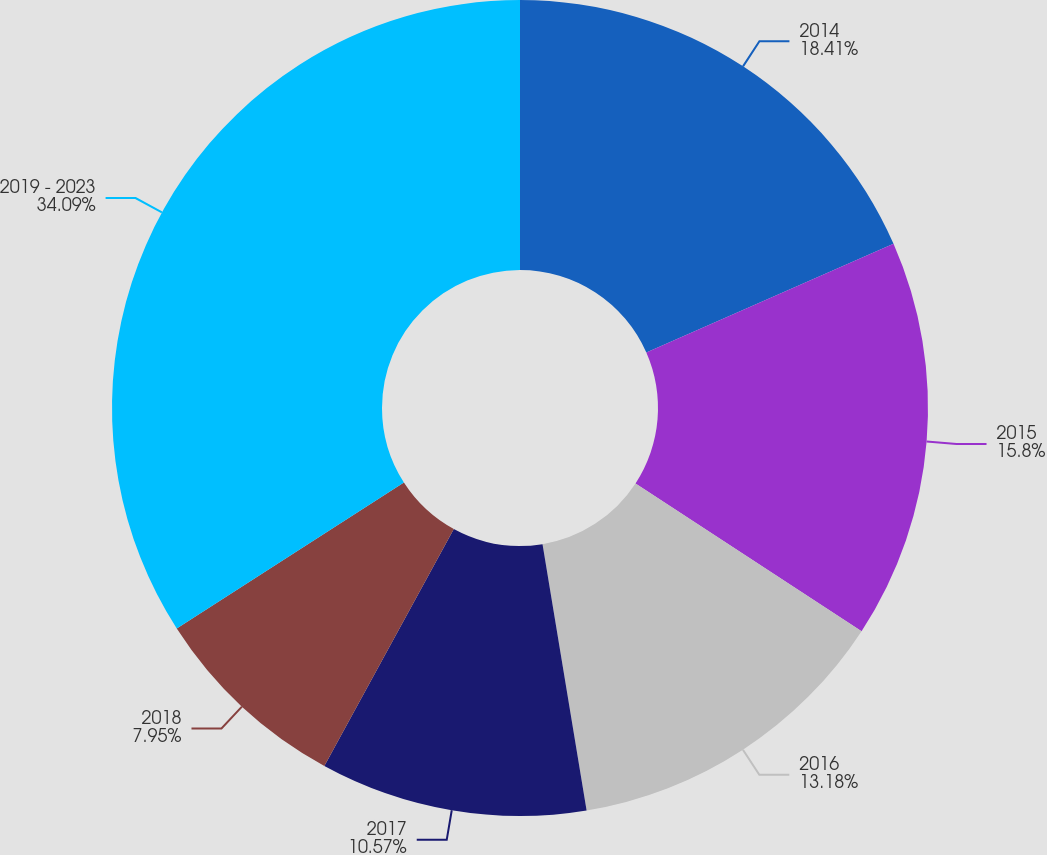Convert chart. <chart><loc_0><loc_0><loc_500><loc_500><pie_chart><fcel>2014<fcel>2015<fcel>2016<fcel>2017<fcel>2018<fcel>2019 - 2023<nl><fcel>18.41%<fcel>15.8%<fcel>13.18%<fcel>10.57%<fcel>7.95%<fcel>34.09%<nl></chart> 